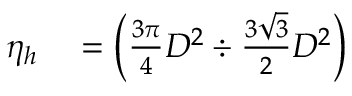Convert formula to latex. <formula><loc_0><loc_0><loc_500><loc_500>\begin{array} { r l } { \eta _ { h } } & = \left ( { \frac { 3 \pi } { 4 } } D ^ { 2 } \div { \frac { 3 { \sqrt { 3 } } } { 2 } } D ^ { 2 } \right ) } \end{array}</formula> 